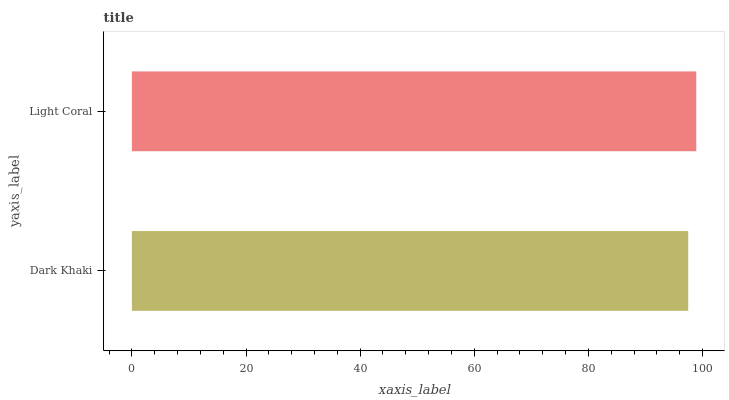Is Dark Khaki the minimum?
Answer yes or no. Yes. Is Light Coral the maximum?
Answer yes or no. Yes. Is Light Coral the minimum?
Answer yes or no. No. Is Light Coral greater than Dark Khaki?
Answer yes or no. Yes. Is Dark Khaki less than Light Coral?
Answer yes or no. Yes. Is Dark Khaki greater than Light Coral?
Answer yes or no. No. Is Light Coral less than Dark Khaki?
Answer yes or no. No. Is Light Coral the high median?
Answer yes or no. Yes. Is Dark Khaki the low median?
Answer yes or no. Yes. Is Dark Khaki the high median?
Answer yes or no. No. Is Light Coral the low median?
Answer yes or no. No. 